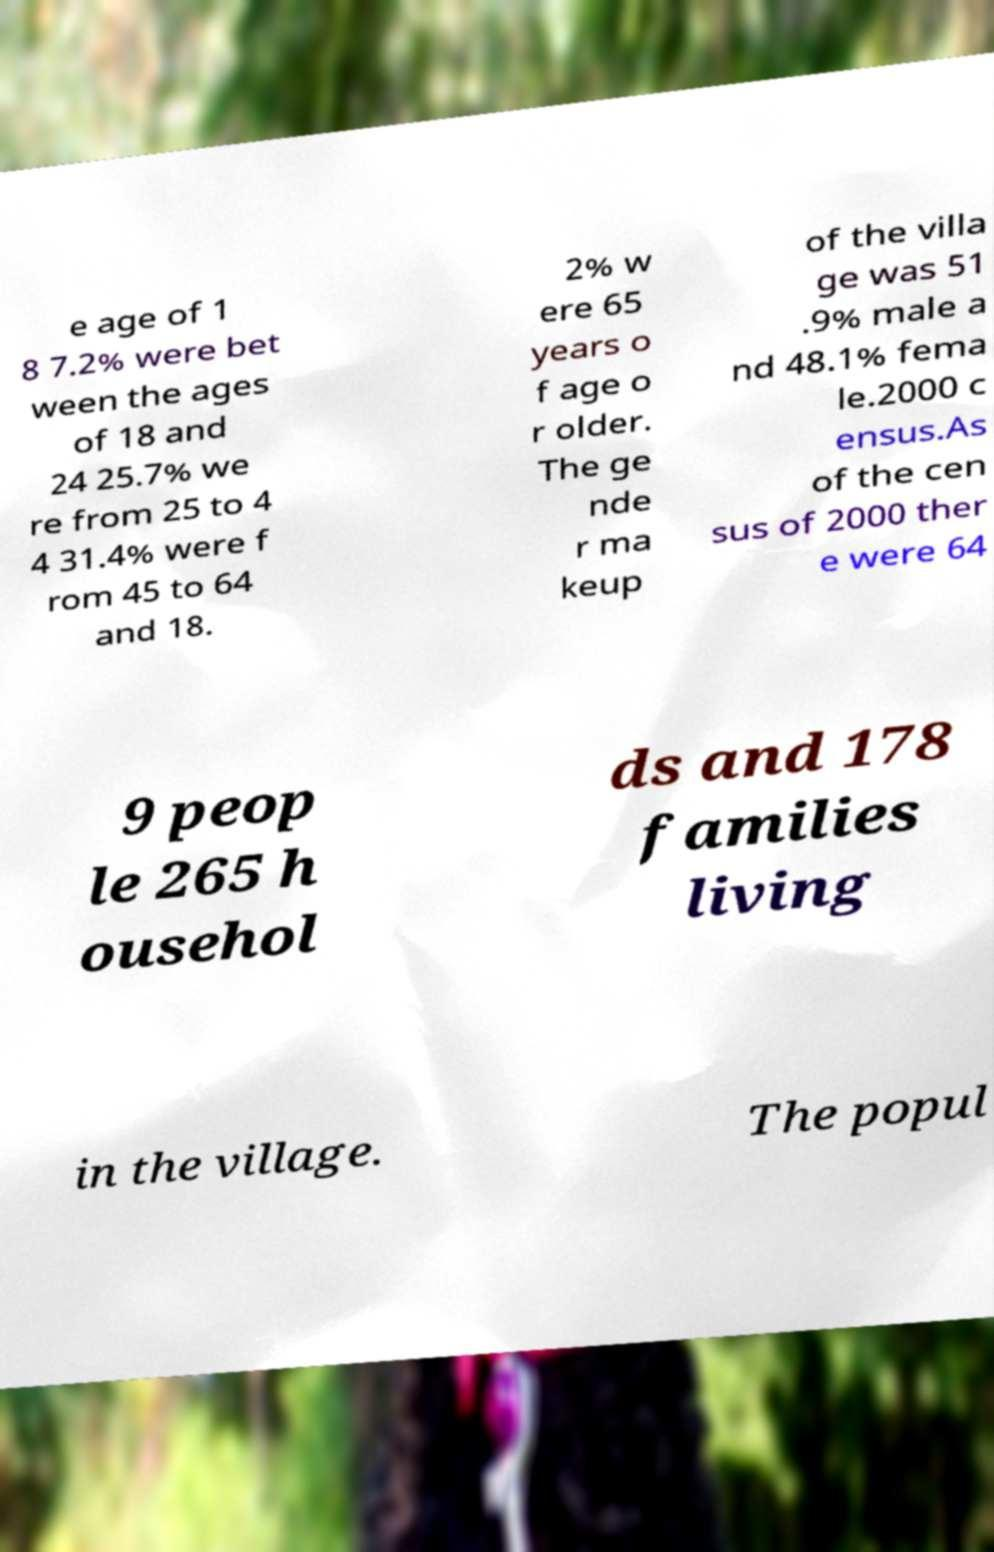Could you assist in decoding the text presented in this image and type it out clearly? e age of 1 8 7.2% were bet ween the ages of 18 and 24 25.7% we re from 25 to 4 4 31.4% were f rom 45 to 64 and 18. 2% w ere 65 years o f age o r older. The ge nde r ma keup of the villa ge was 51 .9% male a nd 48.1% fema le.2000 c ensus.As of the cen sus of 2000 ther e were 64 9 peop le 265 h ousehol ds and 178 families living in the village. The popul 